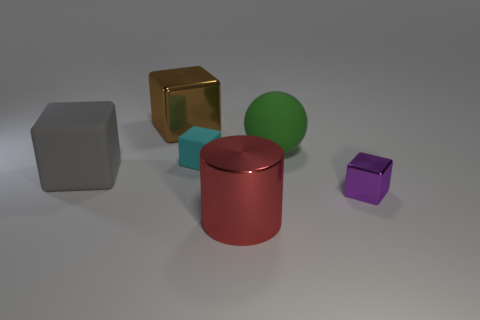Are there any cubes that have the same color as the big sphere?
Your response must be concise. No. There is a green ball that is the same material as the gray object; what size is it?
Your answer should be compact. Large. Is the rubber sphere the same color as the tiny matte block?
Provide a short and direct response. No. Do the metal thing that is on the left side of the large red shiny cylinder and the small purple object have the same shape?
Your response must be concise. Yes. What number of green objects have the same size as the green sphere?
Provide a succinct answer. 0. There is a rubber thing behind the small cyan matte block; is there a matte ball that is behind it?
Ensure brevity in your answer.  No. How many objects are tiny metallic things to the right of the large brown metal thing or big brown shiny blocks?
Your response must be concise. 2. What number of small cyan things are there?
Your answer should be compact. 1. What shape is the small purple object that is the same material as the red thing?
Provide a succinct answer. Cube. There is a shiny block in front of the large matte object on the left side of the big green rubber object; what is its size?
Offer a terse response. Small. 